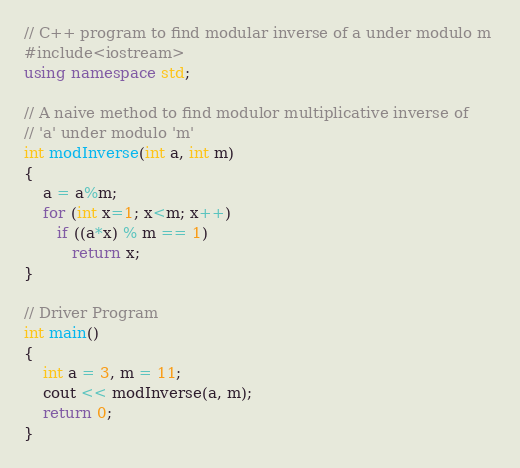<code> <loc_0><loc_0><loc_500><loc_500><_C++_>// C++ program to find modular inverse of a under modulo m 
#include<iostream> 
using namespace std; 
  
// A naive method to find modulor multiplicative inverse of 
// 'a' under modulo 'm' 
int modInverse(int a, int m) 
{ 
    a = a%m; 
    for (int x=1; x<m; x++) 
       if ((a*x) % m == 1) 
          return x; 
} 
  
// Driver Program 
int main() 
{ 
    int a = 3, m = 11; 
    cout << modInverse(a, m); 
    return 0; 
} </code> 